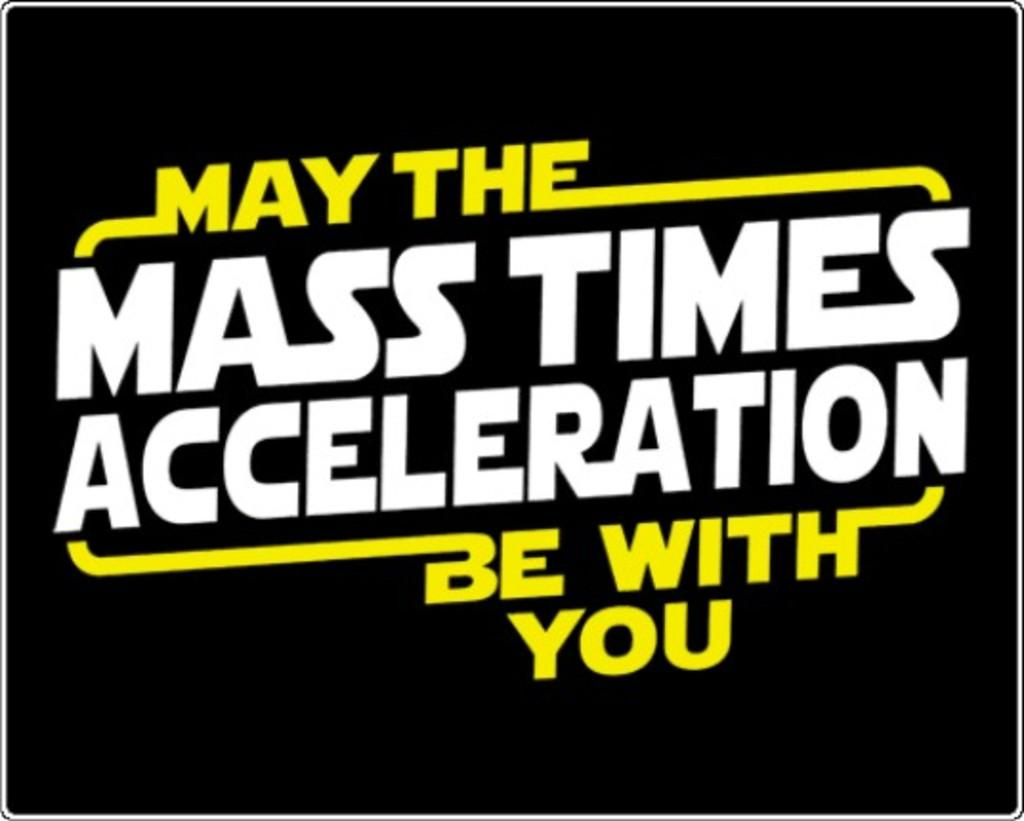<image>
Summarize the visual content of the image. A star wars joke is displayed on a black background. 